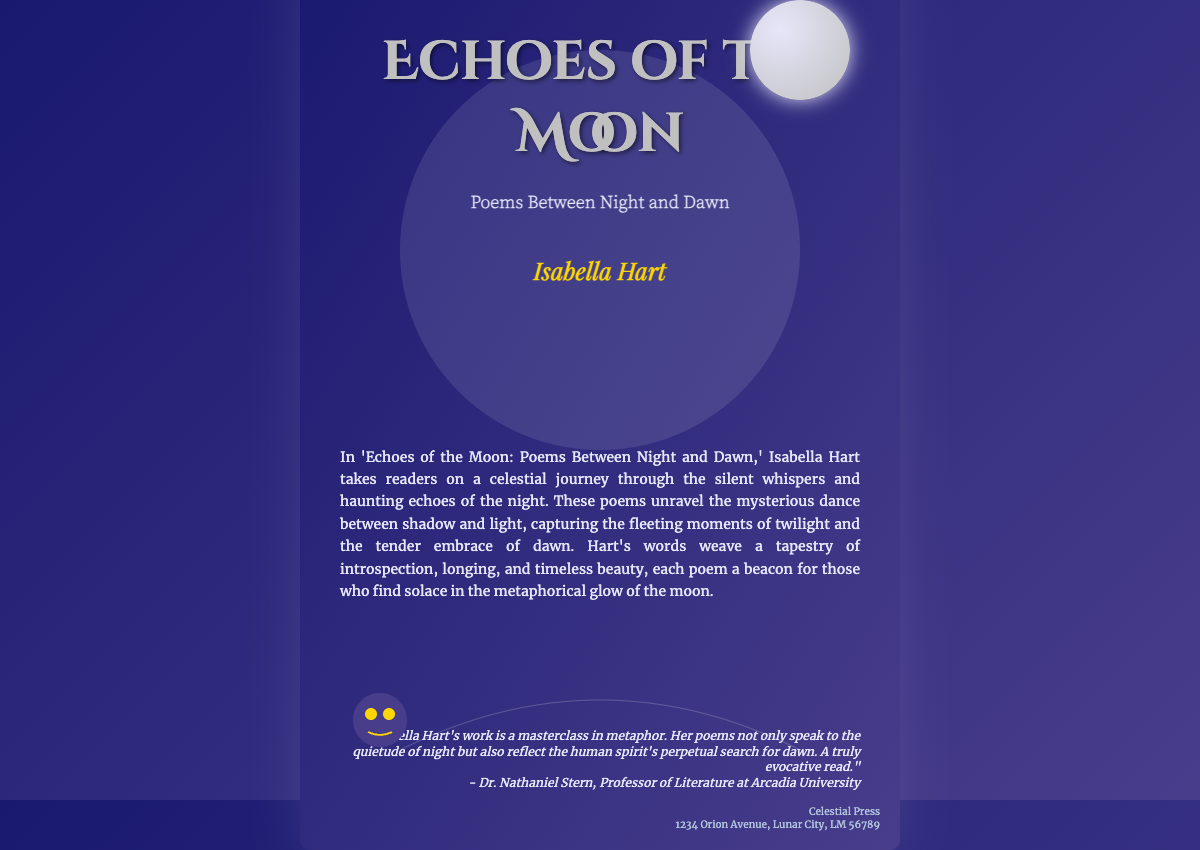What is the title of the book? The title is prominently displayed at the top of the cover.
Answer: Echoes of the Moon Who is the author of the book? The author's name is located beneath the title and subtitle.
Answer: Isabella Hart What is the subtitle of the book? The subtitle is found directly below the title.
Answer: Poems Between Night and Dawn What type of journey do the poems take the reader on? The blurb describes the journey, indicating a celestial theme.
Answer: Celestial journey What does the blurb say the poems capture? The blurb highlights what the poems reveal about time and experience.
Answer: Fleeting moments of twilight and the tender embrace of dawn Who endorsed the book? The endorsement section credited a specific individual for their praise.
Answer: Dr. Nathaniel Stern What is the publisher's name? The publication information at the bottom states the publisher's name.
Answer: Celestial Press Where is the publisher located? The publisher’s address is listed in the publisher section.
Answer: 1234 Orion Avenue, Lunar City, LM 56789 What color is the background gradient of the book cover? The background features a specific gradient of colors described in the style.
Answer: Dark blue to dark purple 